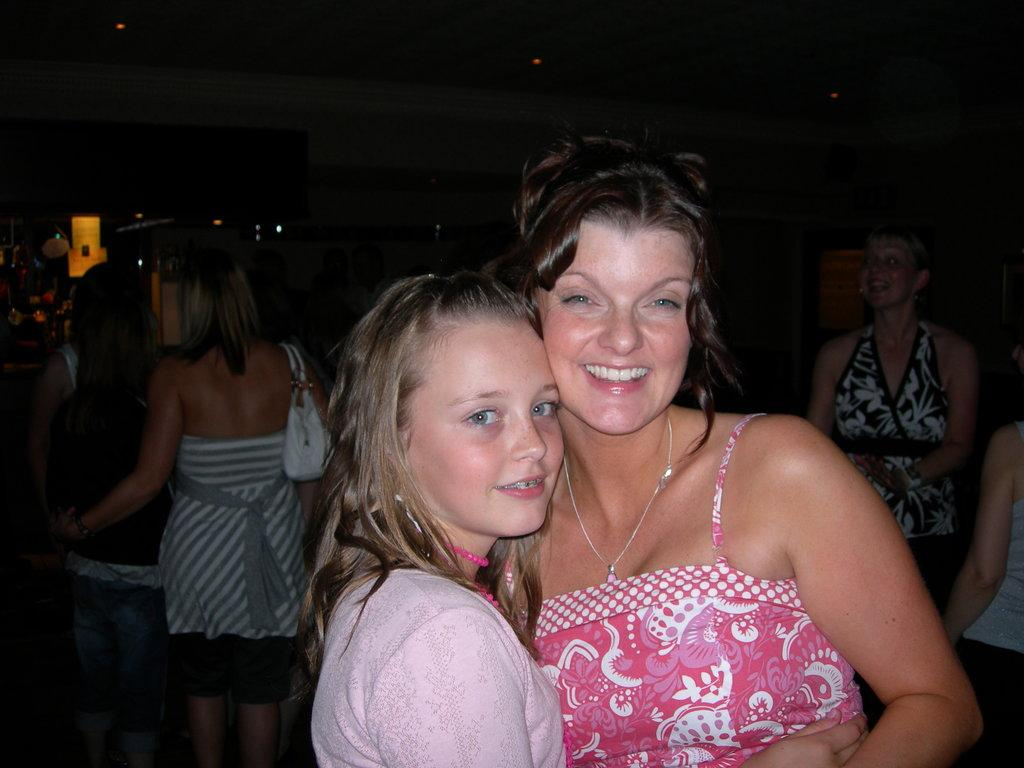Who is present in the image? There are ladies in the image. Can you describe the background of the image? There are persons, a wall, and other objects in the background of the image. What is visible at the top of the image? There is a ceiling with lights at the top of the image. What is the weight of the class being taught in the image? There is no class being taught in the image, and therefore no weight can be determined. 